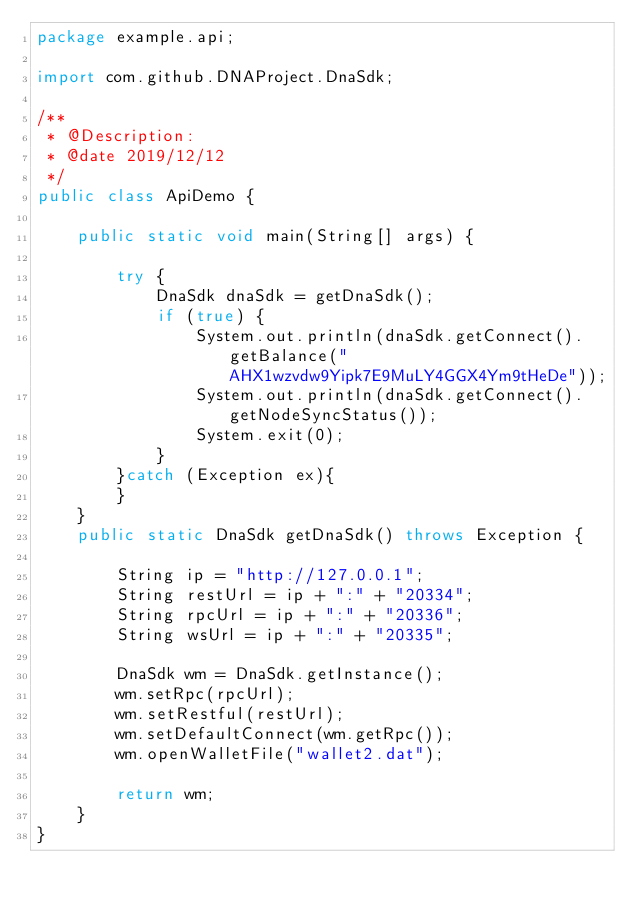Convert code to text. <code><loc_0><loc_0><loc_500><loc_500><_Java_>package example.api;

import com.github.DNAProject.DnaSdk;

/**
 * @Description:
 * @date 2019/12/12
 */
public class ApiDemo {

    public static void main(String[] args) {

        try {
            DnaSdk dnaSdk = getDnaSdk();
            if (true) {
                System.out.println(dnaSdk.getConnect().getBalance("AHX1wzvdw9Yipk7E9MuLY4GGX4Ym9tHeDe"));
                System.out.println(dnaSdk.getConnect().getNodeSyncStatus());
                System.exit(0);
            }
        }catch (Exception ex){
        }
    }
    public static DnaSdk getDnaSdk() throws Exception {

        String ip = "http://127.0.0.1";
        String restUrl = ip + ":" + "20334";
        String rpcUrl = ip + ":" + "20336";
        String wsUrl = ip + ":" + "20335";

        DnaSdk wm = DnaSdk.getInstance();
        wm.setRpc(rpcUrl);
        wm.setRestful(restUrl);
        wm.setDefaultConnect(wm.getRpc());
        wm.openWalletFile("wallet2.dat");

        return wm;
    }
}
</code> 